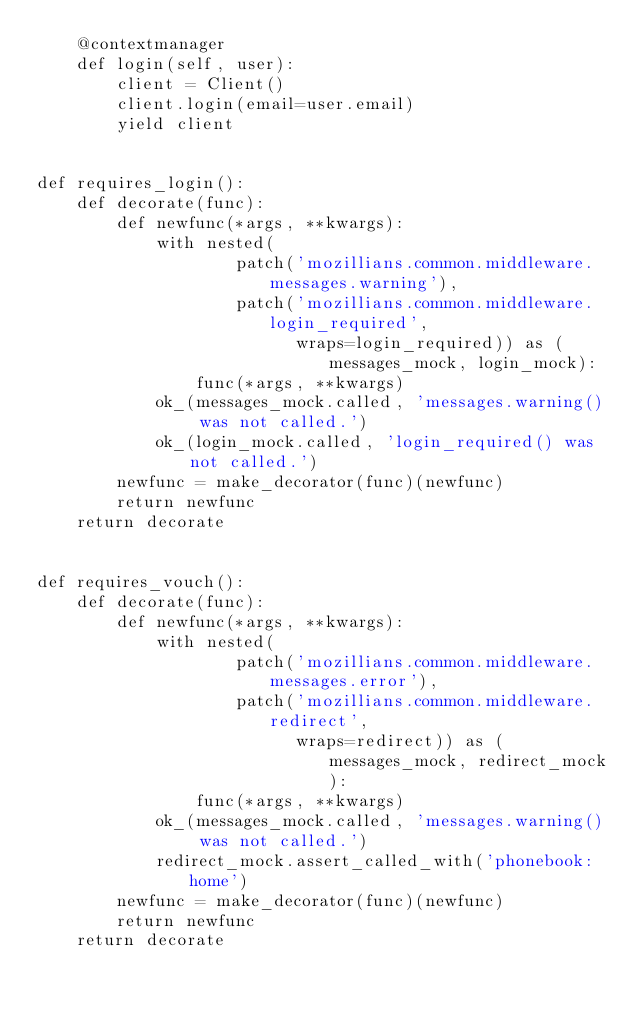Convert code to text. <code><loc_0><loc_0><loc_500><loc_500><_Python_>    @contextmanager
    def login(self, user):
        client = Client()
        client.login(email=user.email)
        yield client


def requires_login():
    def decorate(func):
        def newfunc(*args, **kwargs):
            with nested(
                    patch('mozillians.common.middleware.messages.warning'),
                    patch('mozillians.common.middleware.login_required',
                          wraps=login_required)) as (messages_mock, login_mock):
                func(*args, **kwargs)
            ok_(messages_mock.called, 'messages.warning() was not called.')
            ok_(login_mock.called, 'login_required() was not called.')
        newfunc = make_decorator(func)(newfunc)
        return newfunc
    return decorate


def requires_vouch():
    def decorate(func):
        def newfunc(*args, **kwargs):
            with nested(
                    patch('mozillians.common.middleware.messages.error'),
                    patch('mozillians.common.middleware.redirect',
                          wraps=redirect)) as (messages_mock, redirect_mock):
                func(*args, **kwargs)
            ok_(messages_mock.called, 'messages.warning() was not called.')
            redirect_mock.assert_called_with('phonebook:home')
        newfunc = make_decorator(func)(newfunc)
        return newfunc
    return decorate
</code> 